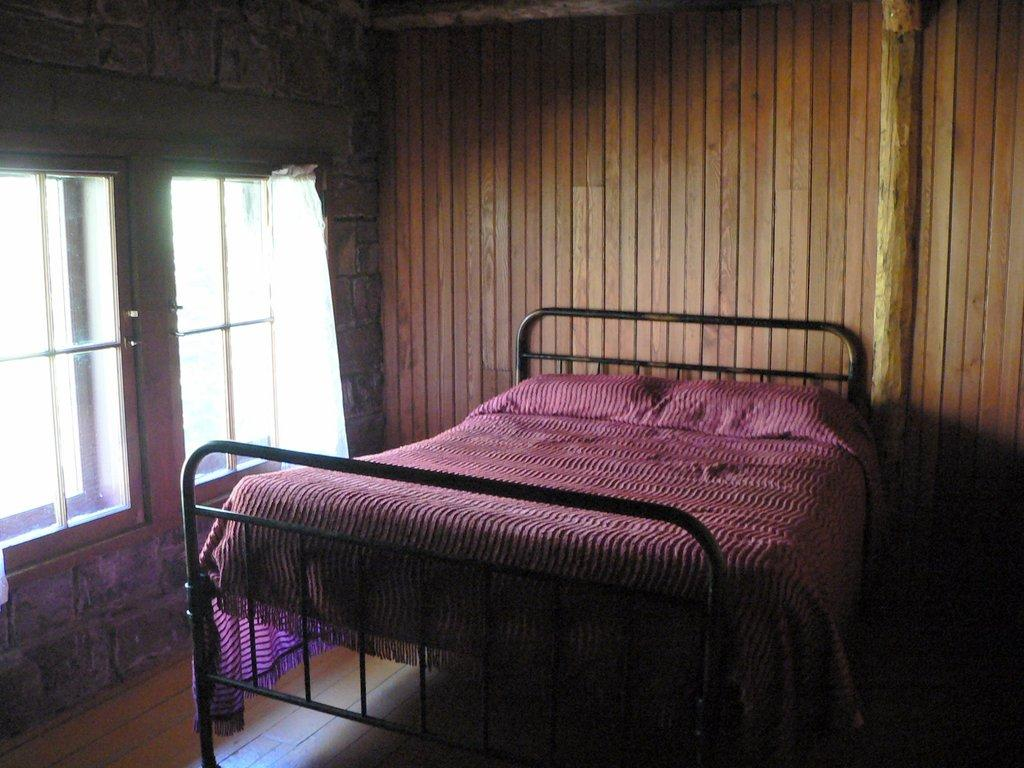What type of space is depicted in the image? The image shows an inside view of a room. What is the main piece of furniture in the image? There is a bed in front of the image. What can be seen on the left side of the image? There are windows on the left side of the image. What is visible in the background of the image? There is a wall visible in the background of the image. What type of fuel is being used to power the bed in the image? There is no fuel or power source associated with the bed in the image; it is a stationary piece of furniture. 